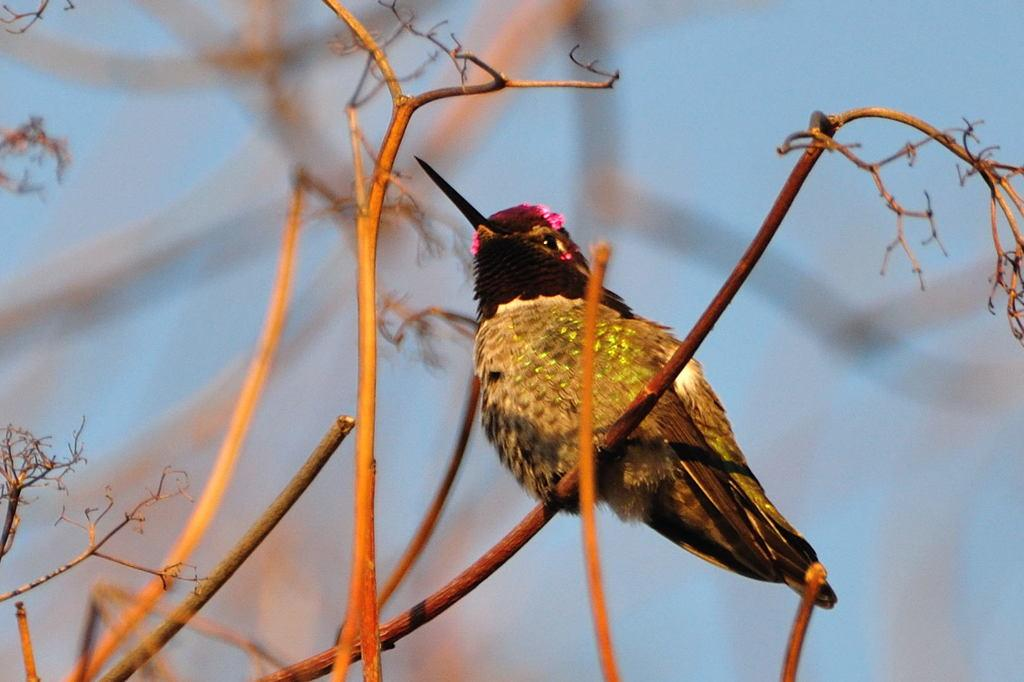What is located in the center of the image? There are branches in the center of the image. What can be seen on the branches? There is a bird on the branch. Can you describe the bird's appearance? The bird has multiple colors. What is visible in the background of the image? The sky is visible in the background of the image. How does the bird's aunt help it sleep at night in the image? There is no mention of an aunt or sleeping in the image; it features a bird on a branch. Can you tell me how much honey the bird is holding in the image? There is no honey present in the image; it only shows a bird on a branch. 